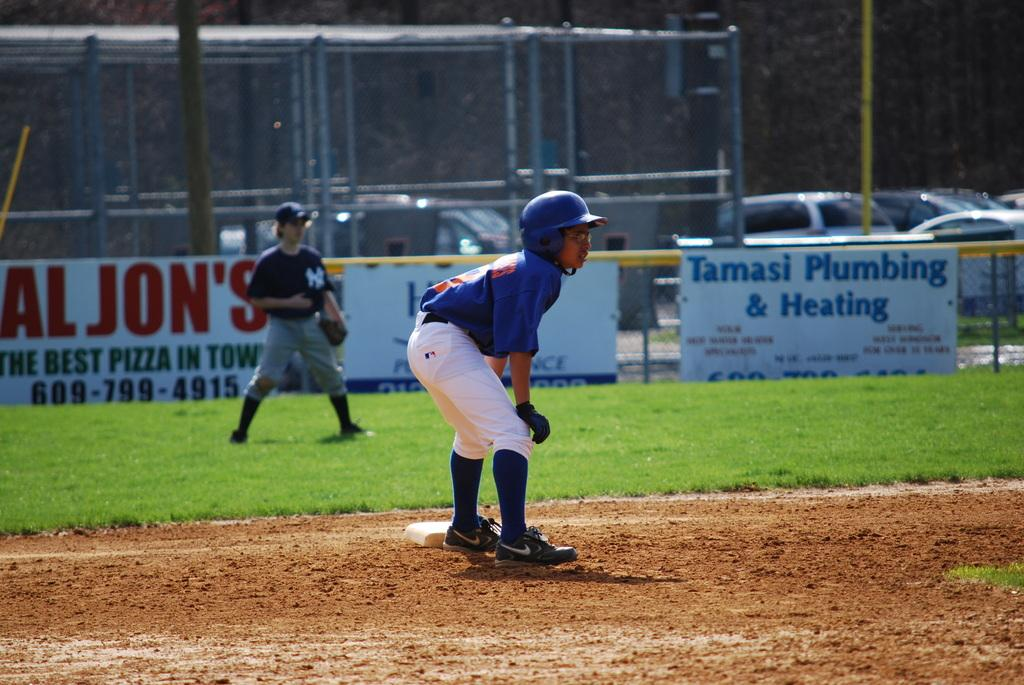<image>
Give a short and clear explanation of the subsequent image. Two young boys are playing baseball by a sign for Tamasi Plumbing & Heating. 